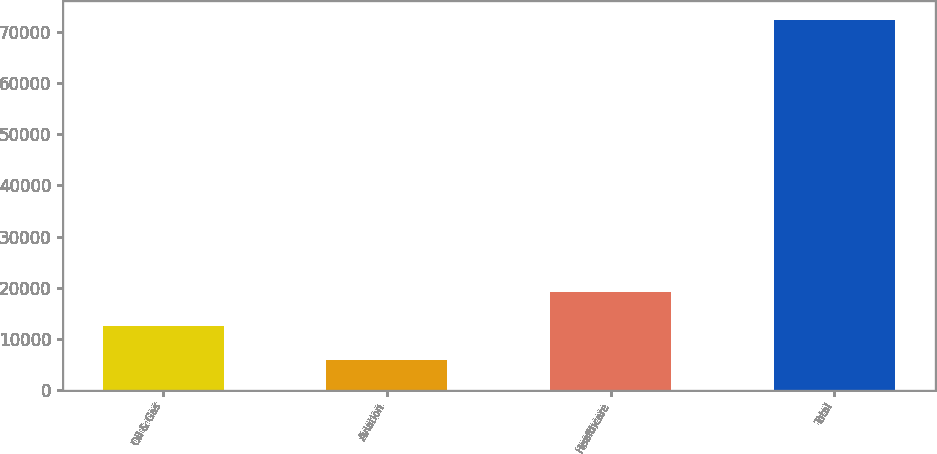Convert chart to OTSL. <chart><loc_0><loc_0><loc_500><loc_500><bar_chart><fcel>Oil & Gas<fcel>Aviation<fcel>Healthcare<fcel>Total<nl><fcel>12626.1<fcel>5996<fcel>19256.2<fcel>72297<nl></chart> 